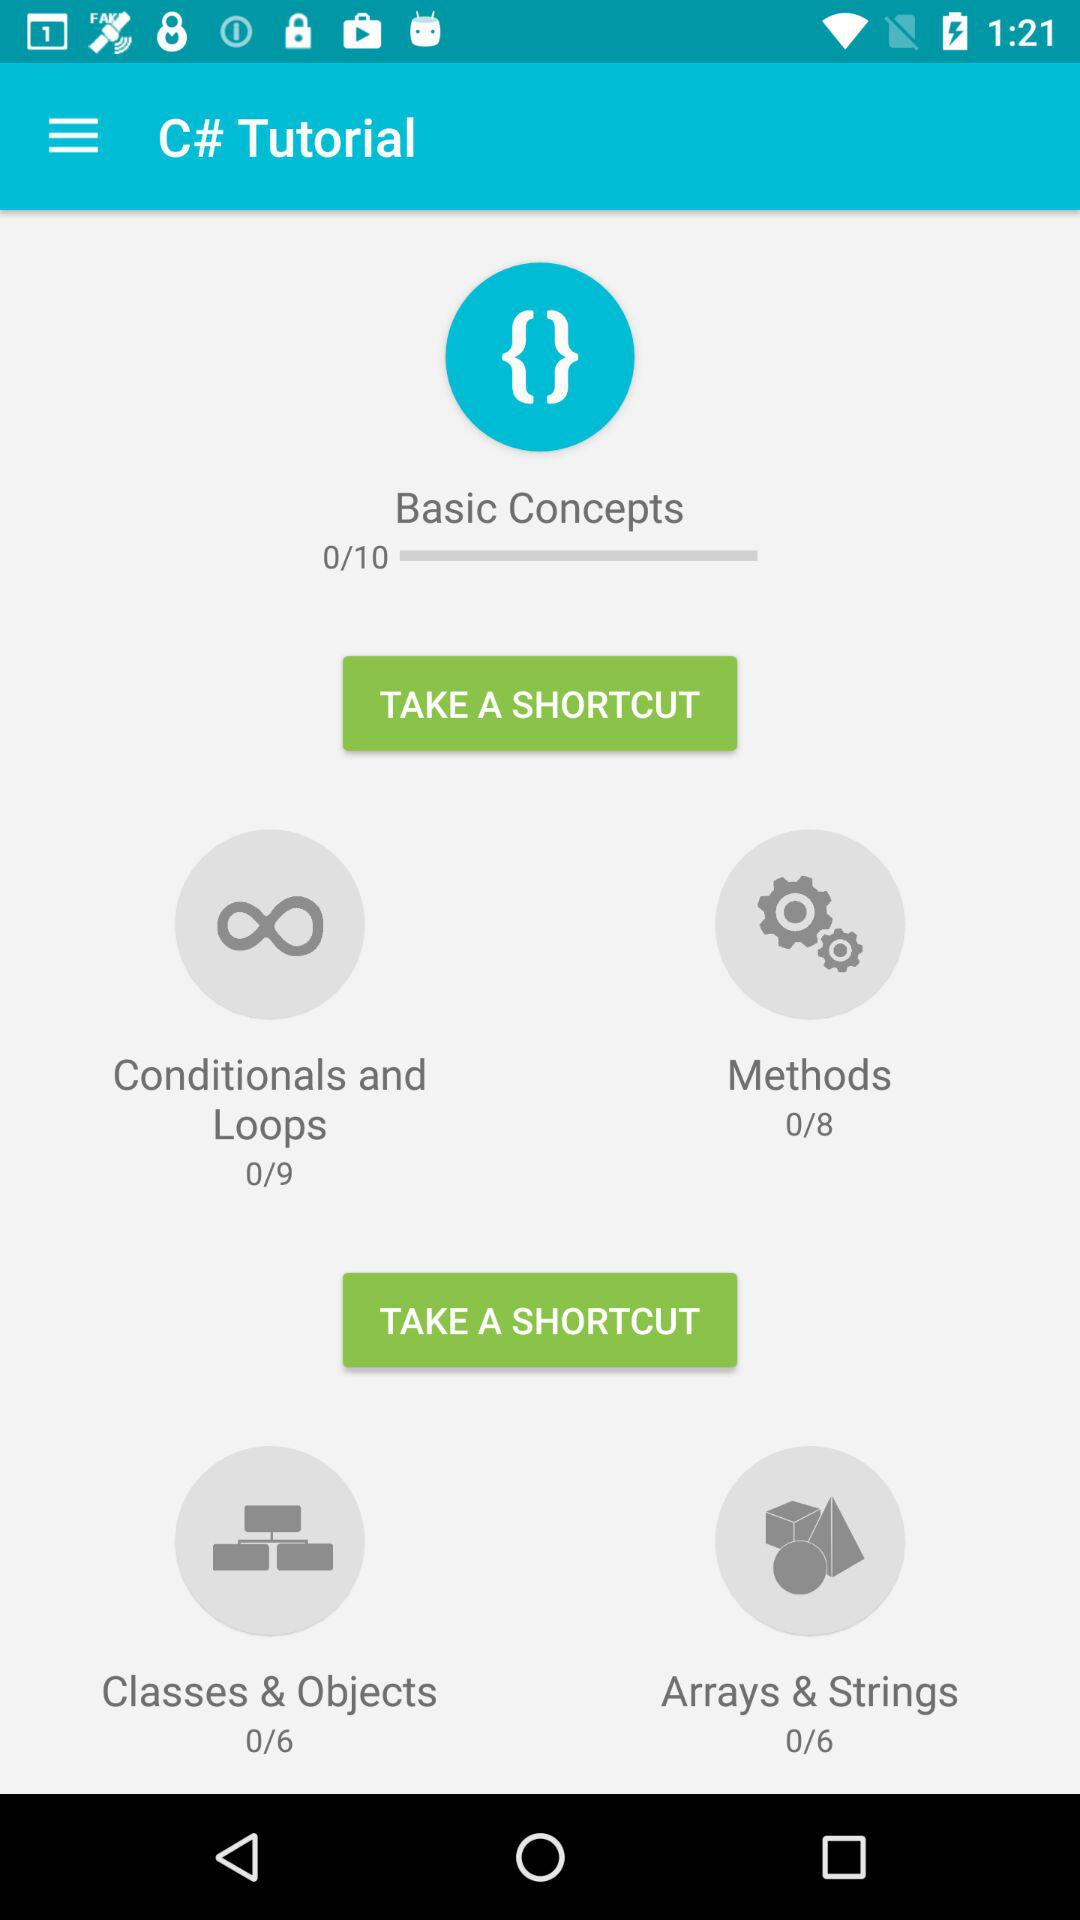How many modules are there in "Conditionals and Loops"? There are 9 modules in "Conditionals and Loops". 